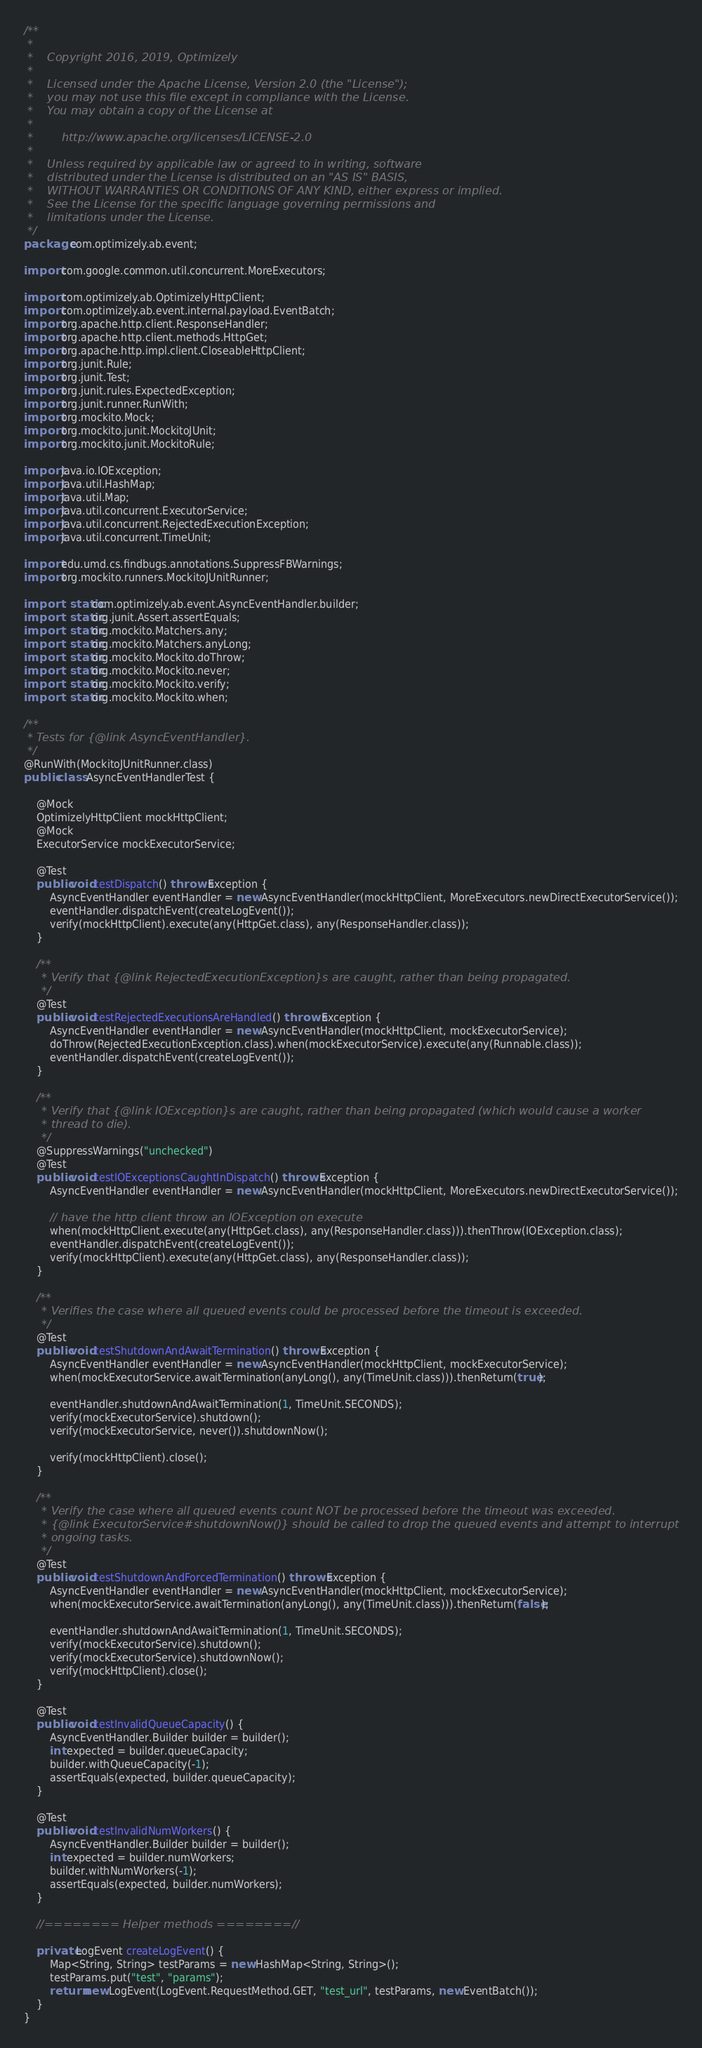Convert code to text. <code><loc_0><loc_0><loc_500><loc_500><_Java_>/**
 *
 *    Copyright 2016, 2019, Optimizely
 *
 *    Licensed under the Apache License, Version 2.0 (the "License");
 *    you may not use this file except in compliance with the License.
 *    You may obtain a copy of the License at
 *
 *        http://www.apache.org/licenses/LICENSE-2.0
 *
 *    Unless required by applicable law or agreed to in writing, software
 *    distributed under the License is distributed on an "AS IS" BASIS,
 *    WITHOUT WARRANTIES OR CONDITIONS OF ANY KIND, either express or implied.
 *    See the License for the specific language governing permissions and
 *    limitations under the License.
 */
package com.optimizely.ab.event;

import com.google.common.util.concurrent.MoreExecutors;

import com.optimizely.ab.OptimizelyHttpClient;
import com.optimizely.ab.event.internal.payload.EventBatch;
import org.apache.http.client.ResponseHandler;
import org.apache.http.client.methods.HttpGet;
import org.apache.http.impl.client.CloseableHttpClient;
import org.junit.Rule;
import org.junit.Test;
import org.junit.rules.ExpectedException;
import org.junit.runner.RunWith;
import org.mockito.Mock;
import org.mockito.junit.MockitoJUnit;
import org.mockito.junit.MockitoRule;

import java.io.IOException;
import java.util.HashMap;
import java.util.Map;
import java.util.concurrent.ExecutorService;
import java.util.concurrent.RejectedExecutionException;
import java.util.concurrent.TimeUnit;

import edu.umd.cs.findbugs.annotations.SuppressFBWarnings;
import org.mockito.runners.MockitoJUnitRunner;

import static com.optimizely.ab.event.AsyncEventHandler.builder;
import static org.junit.Assert.assertEquals;
import static org.mockito.Matchers.any;
import static org.mockito.Matchers.anyLong;
import static org.mockito.Mockito.doThrow;
import static org.mockito.Mockito.never;
import static org.mockito.Mockito.verify;
import static org.mockito.Mockito.when;

/**
 * Tests for {@link AsyncEventHandler}.
 */
@RunWith(MockitoJUnitRunner.class)
public class AsyncEventHandlerTest {

    @Mock
    OptimizelyHttpClient mockHttpClient;
    @Mock
    ExecutorService mockExecutorService;

    @Test
    public void testDispatch() throws Exception {
        AsyncEventHandler eventHandler = new AsyncEventHandler(mockHttpClient, MoreExecutors.newDirectExecutorService());
        eventHandler.dispatchEvent(createLogEvent());
        verify(mockHttpClient).execute(any(HttpGet.class), any(ResponseHandler.class));
    }

    /**
     * Verify that {@link RejectedExecutionException}s are caught, rather than being propagated.
     */
    @Test
    public void testRejectedExecutionsAreHandled() throws Exception {
        AsyncEventHandler eventHandler = new AsyncEventHandler(mockHttpClient, mockExecutorService);
        doThrow(RejectedExecutionException.class).when(mockExecutorService).execute(any(Runnable.class));
        eventHandler.dispatchEvent(createLogEvent());
    }

    /**
     * Verify that {@link IOException}s are caught, rather than being propagated (which would cause a worker
     * thread to die).
     */
    @SuppressWarnings("unchecked")
    @Test
    public void testIOExceptionsCaughtInDispatch() throws Exception {
        AsyncEventHandler eventHandler = new AsyncEventHandler(mockHttpClient, MoreExecutors.newDirectExecutorService());

        // have the http client throw an IOException on execute
        when(mockHttpClient.execute(any(HttpGet.class), any(ResponseHandler.class))).thenThrow(IOException.class);
        eventHandler.dispatchEvent(createLogEvent());
        verify(mockHttpClient).execute(any(HttpGet.class), any(ResponseHandler.class));
    }

    /**
     * Verifies the case where all queued events could be processed before the timeout is exceeded.
     */
    @Test
    public void testShutdownAndAwaitTermination() throws Exception {
        AsyncEventHandler eventHandler = new AsyncEventHandler(mockHttpClient, mockExecutorService);
        when(mockExecutorService.awaitTermination(anyLong(), any(TimeUnit.class))).thenReturn(true);

        eventHandler.shutdownAndAwaitTermination(1, TimeUnit.SECONDS);
        verify(mockExecutorService).shutdown();
        verify(mockExecutorService, never()).shutdownNow();

        verify(mockHttpClient).close();
    }

    /**
     * Verify the case where all queued events count NOT be processed before the timeout was exceeded.
     * {@link ExecutorService#shutdownNow()} should be called to drop the queued events and attempt to interrupt
     * ongoing tasks.
     */
    @Test
    public void testShutdownAndForcedTermination() throws Exception {
        AsyncEventHandler eventHandler = new AsyncEventHandler(mockHttpClient, mockExecutorService);
        when(mockExecutorService.awaitTermination(anyLong(), any(TimeUnit.class))).thenReturn(false);

        eventHandler.shutdownAndAwaitTermination(1, TimeUnit.SECONDS);
        verify(mockExecutorService).shutdown();
        verify(mockExecutorService).shutdownNow();
        verify(mockHttpClient).close();
    }

    @Test
    public void testInvalidQueueCapacity() {
        AsyncEventHandler.Builder builder = builder();
        int expected = builder.queueCapacity;
        builder.withQueueCapacity(-1);
        assertEquals(expected, builder.queueCapacity);
    }

    @Test
    public void testInvalidNumWorkers() {
        AsyncEventHandler.Builder builder = builder();
        int expected = builder.numWorkers;
        builder.withNumWorkers(-1);
        assertEquals(expected, builder.numWorkers);
    }

    //======== Helper methods ========//

    private LogEvent createLogEvent() {
        Map<String, String> testParams = new HashMap<String, String>();
        testParams.put("test", "params");
        return new LogEvent(LogEvent.RequestMethod.GET, "test_url", testParams, new EventBatch());
    }
}
</code> 